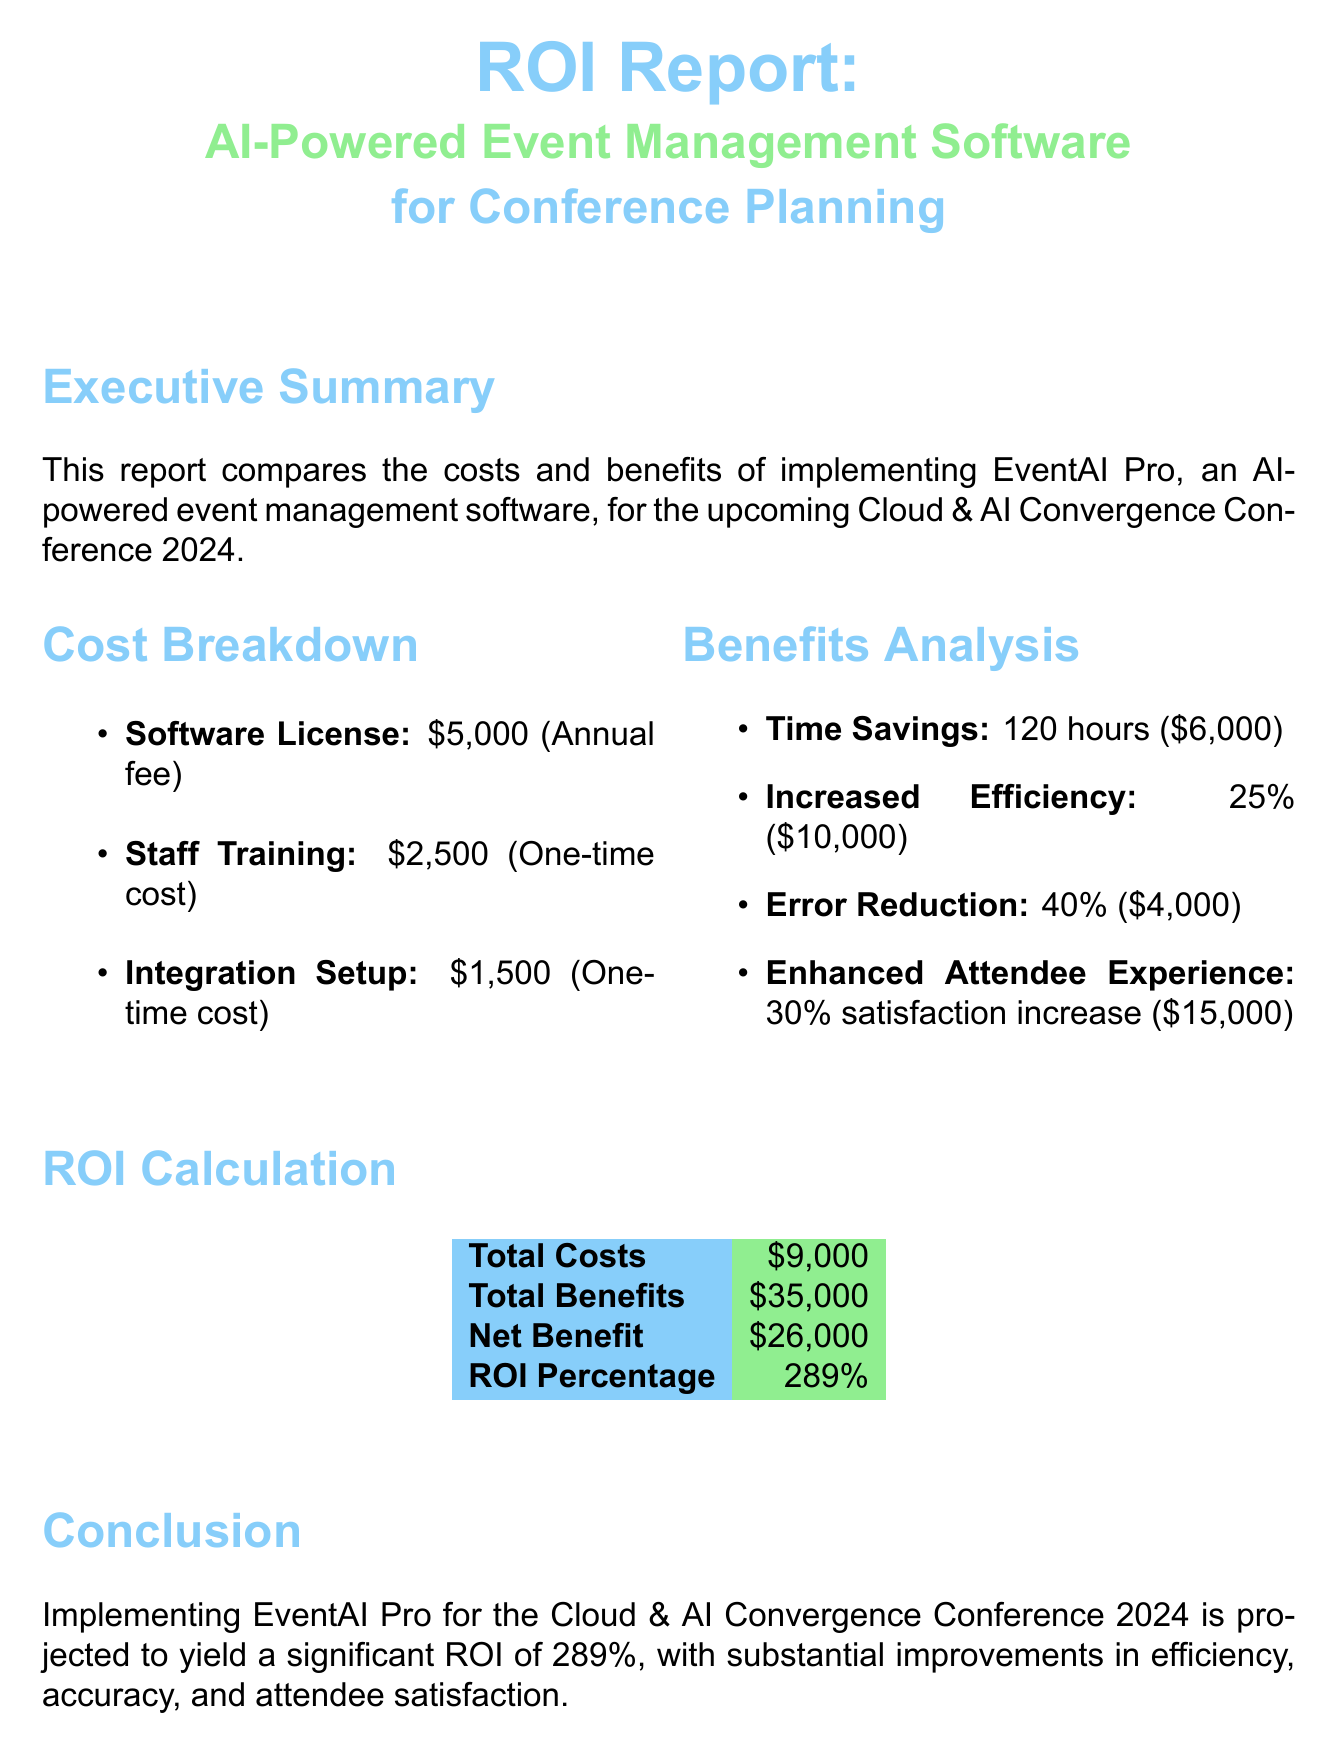What is the annual fee for the software license? The annual fee for the software license is stated in the cost breakdown section of the document.
Answer: $5,000 What is the one-time cost for staff training? The one-time cost for staff training is explicitly mentioned in the cost breakdown section.
Answer: $2,500 How many hours are saved by using the software? The hours saved from using the AI-powered software are detailed under the benefits analysis.
Answer: 120 hours What is the percentage improvement in efficiency due to the software? The percentage improvement in efficiency is provided in the benefits analysis section.
Answer: 25% What is the total cost for implementing the software? The total cost is calculated and listed in the ROI calculation section of the document.
Answer: $9,000 What is the projected net benefit from implementing the software? The projected net benefit is stated in the ROI calculation section.
Answer: $26,000 What is the ROI percentage for using the AI software? The ROI percentage is presented in the ROI calculation section of the report.
Answer: 289% Which benefit yields the highest monetary value? The benefit yielding the highest monetary value is detailed in the benefits analysis.
Answer: Enhanced Attendee Experience What is the satisfaction increase percentage for attendees? The satisfaction increase percentage is specified under the benefits analysis section.
Answer: 30% 